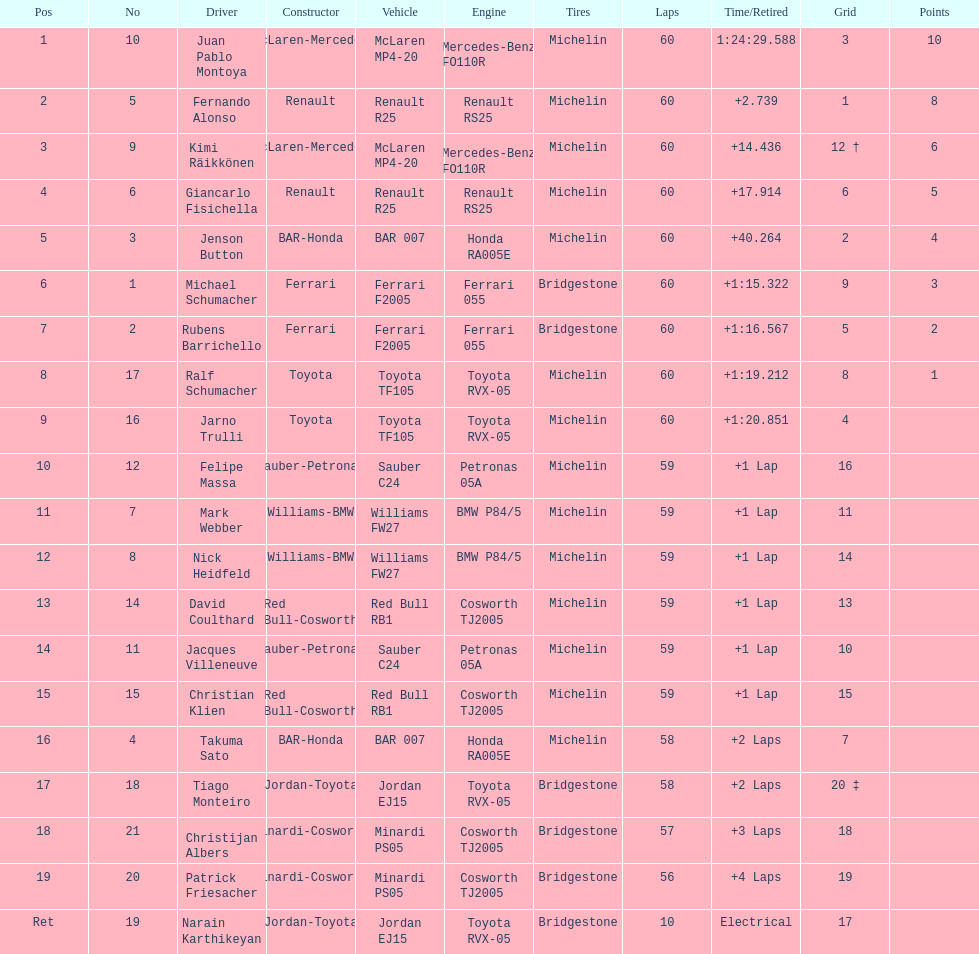After 8th position, how many points does a driver receive? 0. 